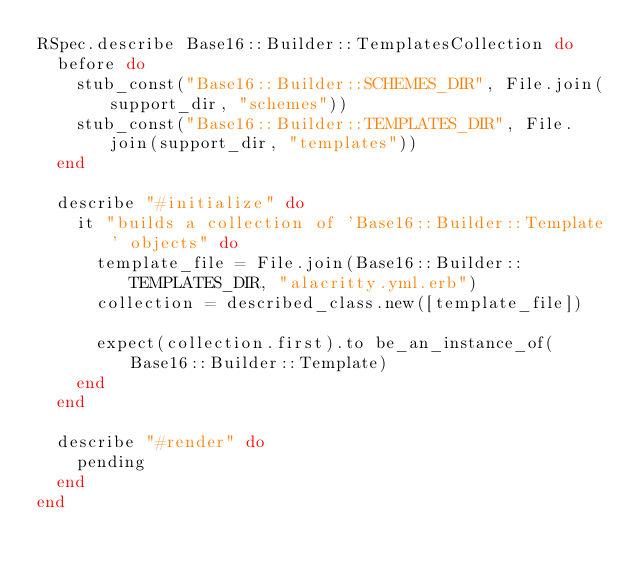<code> <loc_0><loc_0><loc_500><loc_500><_Ruby_>RSpec.describe Base16::Builder::TemplatesCollection do
  before do
    stub_const("Base16::Builder::SCHEMES_DIR", File.join(support_dir, "schemes"))
    stub_const("Base16::Builder::TEMPLATES_DIR", File.join(support_dir, "templates"))
  end

  describe "#initialize" do
    it "builds a collection of 'Base16::Builder::Template' objects" do
      template_file = File.join(Base16::Builder::TEMPLATES_DIR, "alacritty.yml.erb")
      collection = described_class.new([template_file])

      expect(collection.first).to be_an_instance_of(Base16::Builder::Template)
    end
  end

  describe "#render" do
    pending
  end
end
</code> 